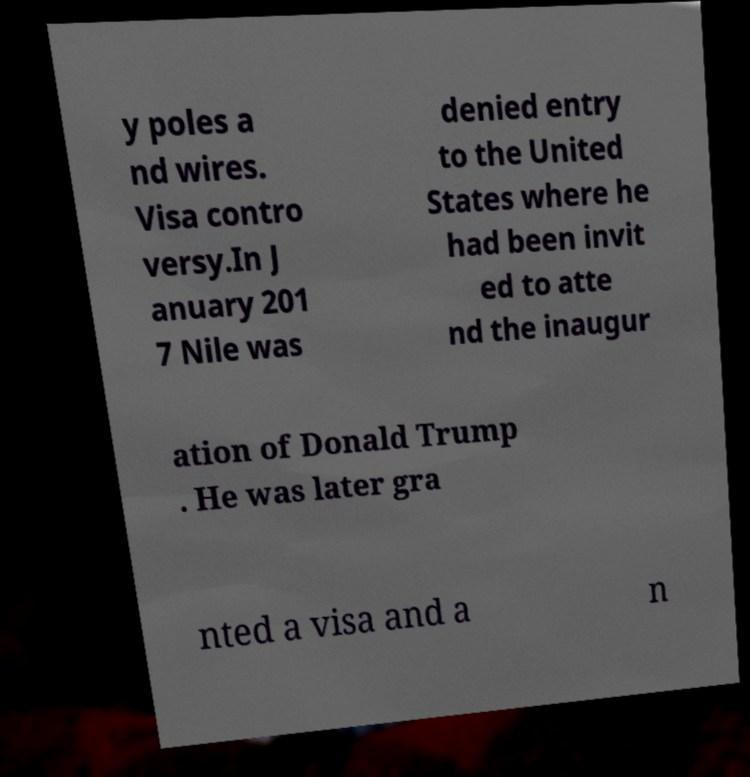Please read and relay the text visible in this image. What does it say? y poles a nd wires. Visa contro versy.In J anuary 201 7 Nile was denied entry to the United States where he had been invit ed to atte nd the inaugur ation of Donald Trump . He was later gra nted a visa and a n 